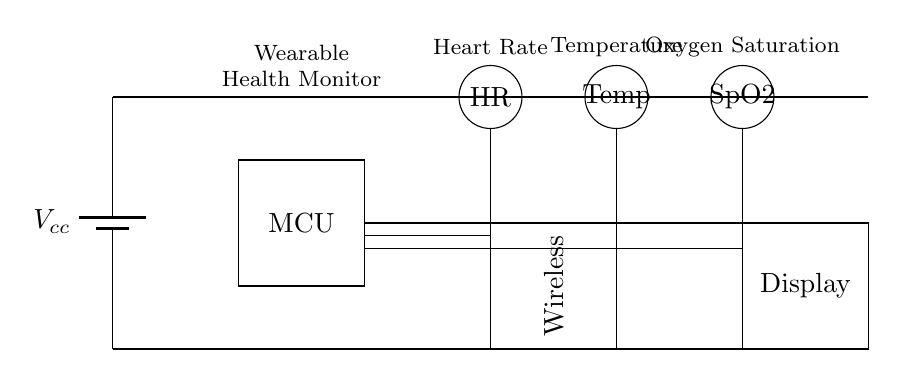What is the voltage supply used in this circuit? The circuit uses a battery, indicated by the symbol at the left side labeled Vcc, which represents the voltage supply for the components.
Answer: Vcc What type of sensors are included in this wearable health monitor? The diagram displays three circular sensors labeled HR, Temp, and SpO2, indicating that it includes sensors for heart rate, temperature, and oxygen saturation.
Answer: Heart Rate, Temperature, Oxygen Saturation How many main components are shown in the diagram? The diagram contains five main components: the power supply, microcontroller, three sensors, a wireless module, and a display. Counting these components leads to the answer.
Answer: Five What is the purpose of the wireless module in the circuit? The wireless module is needed to transmit data collected from the sensors, as it connects to the microcontroller and allows communication with external devices.
Answer: Data transmission Which component is responsible for processing the sensor data? The microcontroller (MCU) processes information received from the sensors before sending it to other components like the display or the wireless module. It is the rectangular shape labeled MCU in the diagram.
Answer: Microcontroller How are the sensors connected to the microcontroller? The sensors connect to the microcontroller through direct lines, indicating that the output of each sensor feeds into the input of the microcontroller for data processing. These connections, shown as the lines between the components, illustrate this relationship.
Answer: Direct connections What type of monitoring does this hybrid circuit facilitate for cancer patients? This circuit is designed to continuously monitor vital signs, such as heart rate, temperature, and oxygen saturation levels, which are crucial for managing the health of cancer patients.
Answer: Vital signs monitoring 